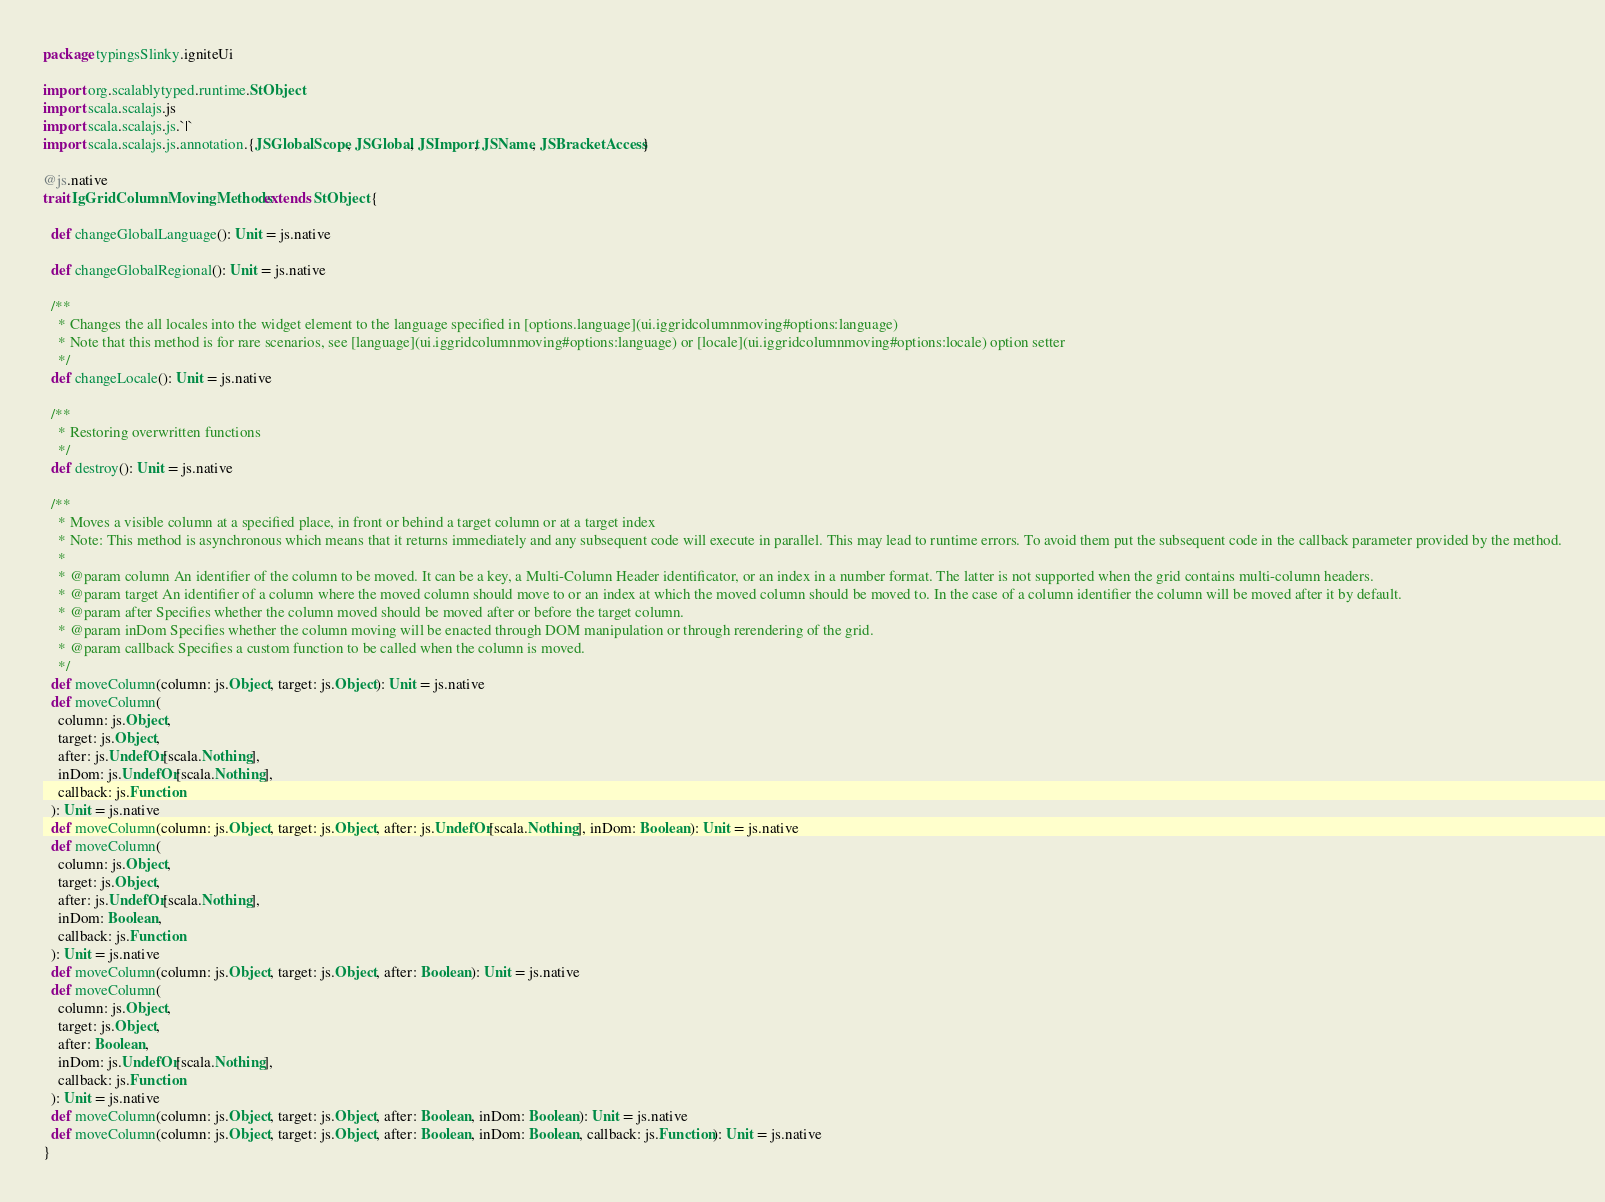Convert code to text. <code><loc_0><loc_0><loc_500><loc_500><_Scala_>package typingsSlinky.igniteUi

import org.scalablytyped.runtime.StObject
import scala.scalajs.js
import scala.scalajs.js.`|`
import scala.scalajs.js.annotation.{JSGlobalScope, JSGlobal, JSImport, JSName, JSBracketAccess}

@js.native
trait IgGridColumnMovingMethods extends StObject {
  
  def changeGlobalLanguage(): Unit = js.native
  
  def changeGlobalRegional(): Unit = js.native
  
  /**
    * Changes the all locales into the widget element to the language specified in [options.language](ui.iggridcolumnmoving#options:language)
    * Note that this method is for rare scenarios, see [language](ui.iggridcolumnmoving#options:language) or [locale](ui.iggridcolumnmoving#options:locale) option setter
    */
  def changeLocale(): Unit = js.native
  
  /**
    * Restoring overwritten functions
    */
  def destroy(): Unit = js.native
  
  /**
    * Moves a visible column at a specified place, in front or behind a target column or at a target index
    * Note: This method is asynchronous which means that it returns immediately and any subsequent code will execute in parallel. This may lead to runtime errors. To avoid them put the subsequent code in the callback parameter provided by the method.
    *
    * @param column An identifier of the column to be moved. It can be a key, a Multi-Column Header identificator, or an index in a number format. The latter is not supported when the grid contains multi-column headers.
    * @param target An identifier of a column where the moved column should move to or an index at which the moved column should be moved to. In the case of a column identifier the column will be moved after it by default.
    * @param after Specifies whether the column moved should be moved after or before the target column.
    * @param inDom Specifies whether the column moving will be enacted through DOM manipulation or through rerendering of the grid.
    * @param callback Specifies a custom function to be called when the column is moved.
    */
  def moveColumn(column: js.Object, target: js.Object): Unit = js.native
  def moveColumn(
    column: js.Object,
    target: js.Object,
    after: js.UndefOr[scala.Nothing],
    inDom: js.UndefOr[scala.Nothing],
    callback: js.Function
  ): Unit = js.native
  def moveColumn(column: js.Object, target: js.Object, after: js.UndefOr[scala.Nothing], inDom: Boolean): Unit = js.native
  def moveColumn(
    column: js.Object,
    target: js.Object,
    after: js.UndefOr[scala.Nothing],
    inDom: Boolean,
    callback: js.Function
  ): Unit = js.native
  def moveColumn(column: js.Object, target: js.Object, after: Boolean): Unit = js.native
  def moveColumn(
    column: js.Object,
    target: js.Object,
    after: Boolean,
    inDom: js.UndefOr[scala.Nothing],
    callback: js.Function
  ): Unit = js.native
  def moveColumn(column: js.Object, target: js.Object, after: Boolean, inDom: Boolean): Unit = js.native
  def moveColumn(column: js.Object, target: js.Object, after: Boolean, inDom: Boolean, callback: js.Function): Unit = js.native
}
</code> 